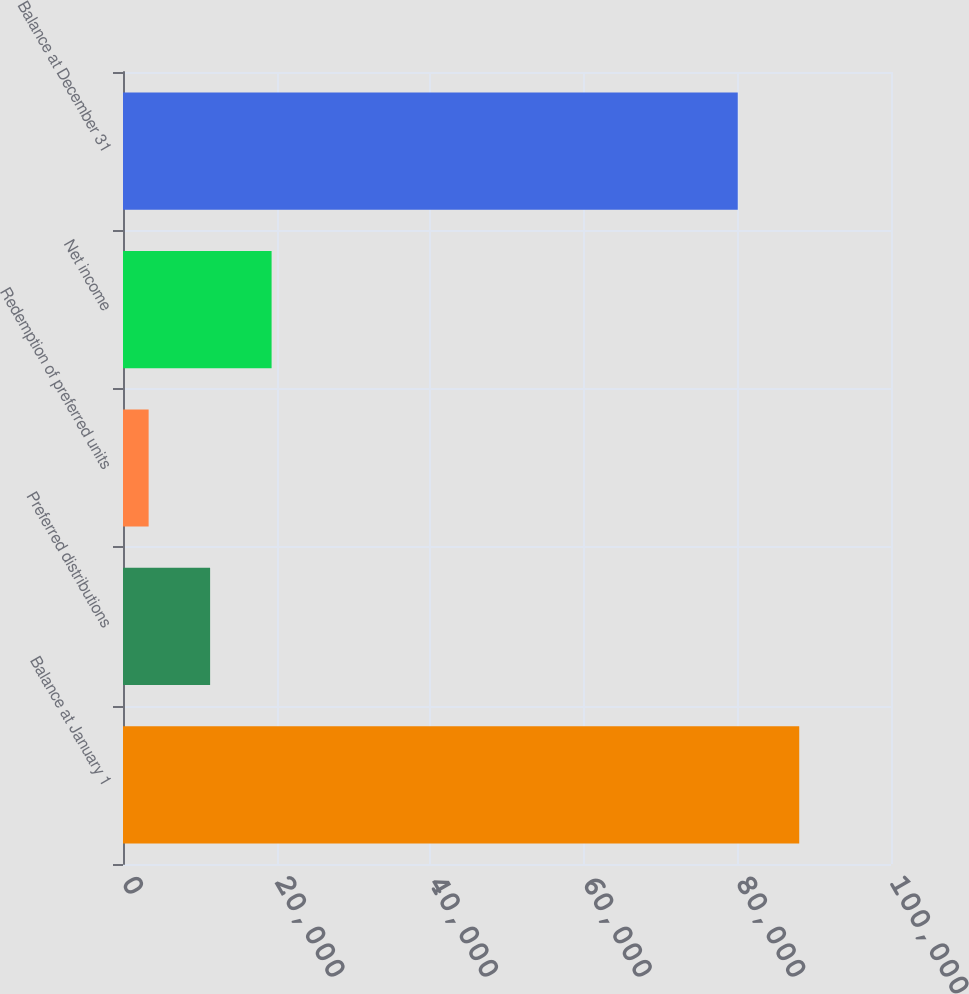Convert chart to OTSL. <chart><loc_0><loc_0><loc_500><loc_500><bar_chart><fcel>Balance at January 1<fcel>Preferred distributions<fcel>Redemption of preferred units<fcel>Net income<fcel>Balance at December 31<nl><fcel>88050.6<fcel>11342.6<fcel>3338<fcel>19347.2<fcel>80046<nl></chart> 